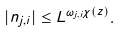Convert formula to latex. <formula><loc_0><loc_0><loc_500><loc_500>| n _ { j , i } | \leq L ^ { \omega _ { j , i } \chi ( z ) } .</formula> 